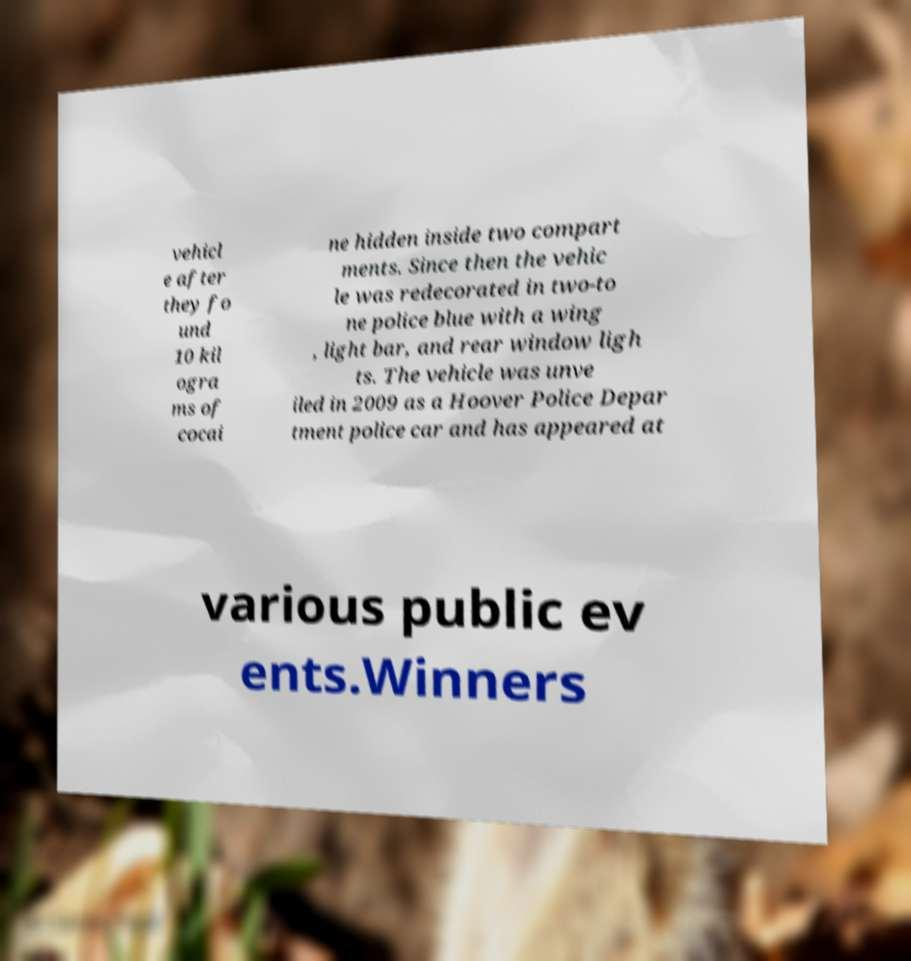Can you read and provide the text displayed in the image?This photo seems to have some interesting text. Can you extract and type it out for me? vehicl e after they fo und 10 kil ogra ms of cocai ne hidden inside two compart ments. Since then the vehic le was redecorated in two-to ne police blue with a wing , light bar, and rear window ligh ts. The vehicle was unve iled in 2009 as a Hoover Police Depar tment police car and has appeared at various public ev ents.Winners 